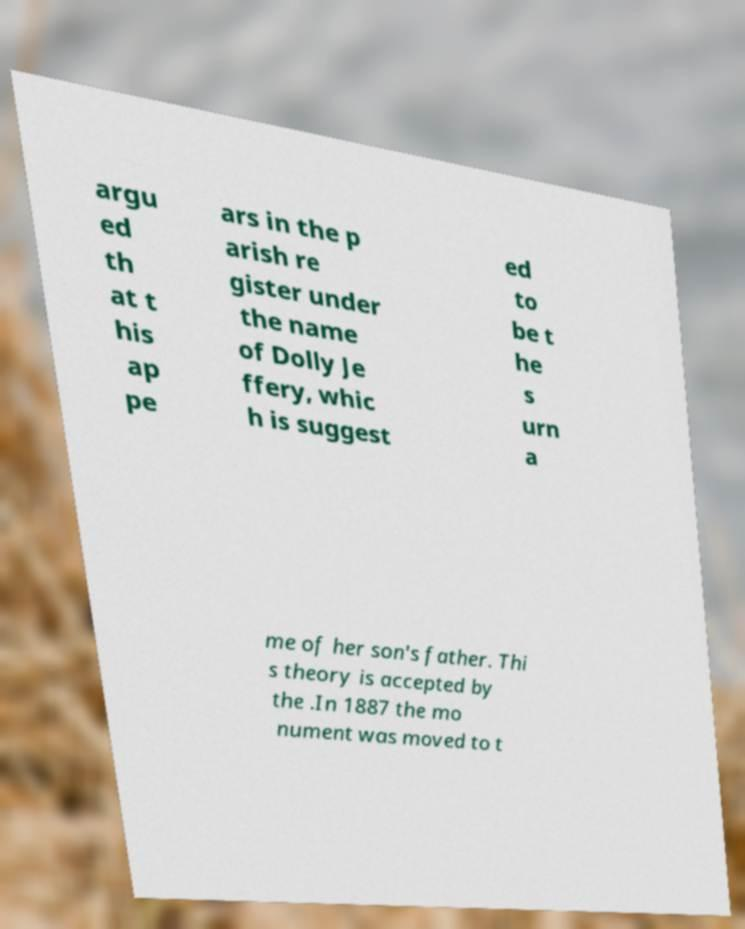Please read and relay the text visible in this image. What does it say? argu ed th at t his ap pe ars in the p arish re gister under the name of Dolly Je ffery, whic h is suggest ed to be t he s urn a me of her son's father. Thi s theory is accepted by the .In 1887 the mo nument was moved to t 